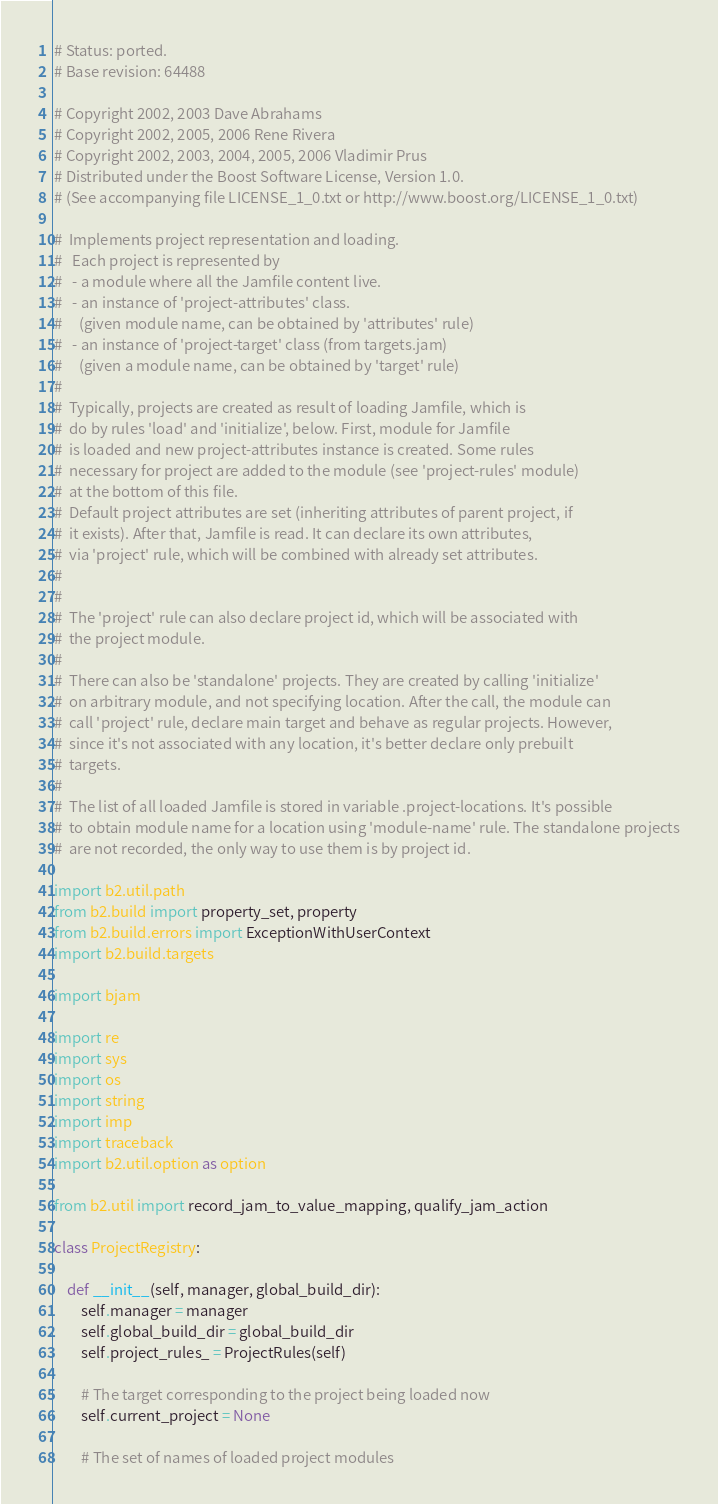Convert code to text. <code><loc_0><loc_0><loc_500><loc_500><_Python_># Status: ported.
# Base revision: 64488

# Copyright 2002, 2003 Dave Abrahams 
# Copyright 2002, 2005, 2006 Rene Rivera 
# Copyright 2002, 2003, 2004, 2005, 2006 Vladimir Prus 
# Distributed under the Boost Software License, Version 1.0. 
# (See accompanying file LICENSE_1_0.txt or http://www.boost.org/LICENSE_1_0.txt) 

#  Implements project representation and loading.
#   Each project is represented by 
#   - a module where all the Jamfile content live. 
#   - an instance of 'project-attributes' class.
#     (given module name, can be obtained by 'attributes' rule)
#   - an instance of 'project-target' class (from targets.jam)
#     (given a module name, can be obtained by 'target' rule)
#
#  Typically, projects are created as result of loading Jamfile, which is
#  do by rules 'load' and 'initialize', below. First, module for Jamfile
#  is loaded and new project-attributes instance is created. Some rules
#  necessary for project are added to the module (see 'project-rules' module)
#  at the bottom of this file.
#  Default project attributes are set (inheriting attributes of parent project, if
#  it exists). After that, Jamfile is read. It can declare its own attributes,
#  via 'project' rule, which will be combined with already set attributes.
#
#
#  The 'project' rule can also declare project id, which will be associated with 
#  the project module.
#
#  There can also be 'standalone' projects. They are created by calling 'initialize'
#  on arbitrary module, and not specifying location. After the call, the module can
#  call 'project' rule, declare main target and behave as regular projects. However,
#  since it's not associated with any location, it's better declare only prebuilt 
#  targets.
#
#  The list of all loaded Jamfile is stored in variable .project-locations. It's possible
#  to obtain module name for a location using 'module-name' rule. The standalone projects
#  are not recorded, the only way to use them is by project id.

import b2.util.path
from b2.build import property_set, property
from b2.build.errors import ExceptionWithUserContext
import b2.build.targets

import bjam

import re
import sys
import os
import string
import imp
import traceback
import b2.util.option as option

from b2.util import record_jam_to_value_mapping, qualify_jam_action

class ProjectRegistry:

    def __init__(self, manager, global_build_dir):
        self.manager = manager
        self.global_build_dir = global_build_dir
        self.project_rules_ = ProjectRules(self)

        # The target corresponding to the project being loaded now
        self.current_project = None
        
        # The set of names of loaded project modules</code> 